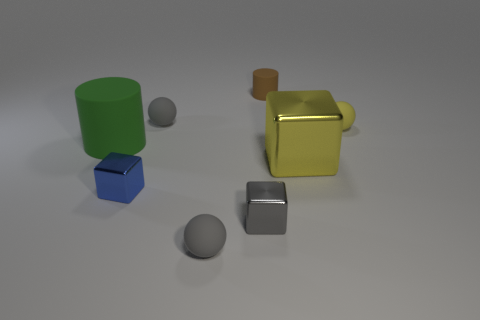How many tiny gray matte things are behind the blue shiny cube and in front of the tiny blue object?
Offer a terse response. 0. Is there a ball that has the same color as the large block?
Offer a very short reply. Yes. What is the shape of the blue metal thing that is the same size as the gray metal object?
Provide a succinct answer. Cube. There is a small gray metal cube; are there any small blue metal blocks behind it?
Make the answer very short. Yes. Is the small ball that is in front of the green cylinder made of the same material as the gray object behind the large green thing?
Your answer should be very brief. Yes. How many gray things are the same size as the green cylinder?
Provide a short and direct response. 0. What is the shape of the tiny rubber object that is the same color as the big shiny thing?
Keep it short and to the point. Sphere. What is the gray ball in front of the yellow block made of?
Provide a succinct answer. Rubber. What number of other objects have the same shape as the big metallic object?
Provide a succinct answer. 2. There is a tiny yellow object that is the same material as the small brown cylinder; what shape is it?
Offer a very short reply. Sphere. 